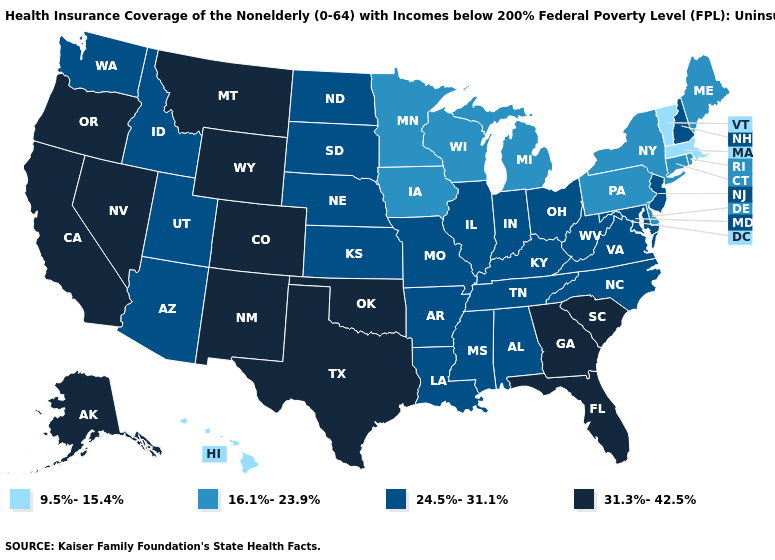Does New Hampshire have a higher value than Connecticut?
Quick response, please. Yes. Does Wisconsin have the same value as New York?
Write a very short answer. Yes. What is the value of Utah?
Write a very short answer. 24.5%-31.1%. Which states have the highest value in the USA?
Short answer required. Alaska, California, Colorado, Florida, Georgia, Montana, Nevada, New Mexico, Oklahoma, Oregon, South Carolina, Texas, Wyoming. Does New York have the highest value in the Northeast?
Quick response, please. No. Name the states that have a value in the range 9.5%-15.4%?
Quick response, please. Hawaii, Massachusetts, Vermont. Which states have the lowest value in the USA?
Be succinct. Hawaii, Massachusetts, Vermont. Does Alaska have a higher value than Vermont?
Answer briefly. Yes. Which states hav the highest value in the West?
Write a very short answer. Alaska, California, Colorado, Montana, Nevada, New Mexico, Oregon, Wyoming. Name the states that have a value in the range 9.5%-15.4%?
Answer briefly. Hawaii, Massachusetts, Vermont. Name the states that have a value in the range 9.5%-15.4%?
Be succinct. Hawaii, Massachusetts, Vermont. Name the states that have a value in the range 24.5%-31.1%?
Write a very short answer. Alabama, Arizona, Arkansas, Idaho, Illinois, Indiana, Kansas, Kentucky, Louisiana, Maryland, Mississippi, Missouri, Nebraska, New Hampshire, New Jersey, North Carolina, North Dakota, Ohio, South Dakota, Tennessee, Utah, Virginia, Washington, West Virginia. What is the lowest value in states that border Louisiana?
Be succinct. 24.5%-31.1%. Does Hawaii have the same value as Vermont?
Be succinct. Yes. Which states have the lowest value in the USA?
Be succinct. Hawaii, Massachusetts, Vermont. 